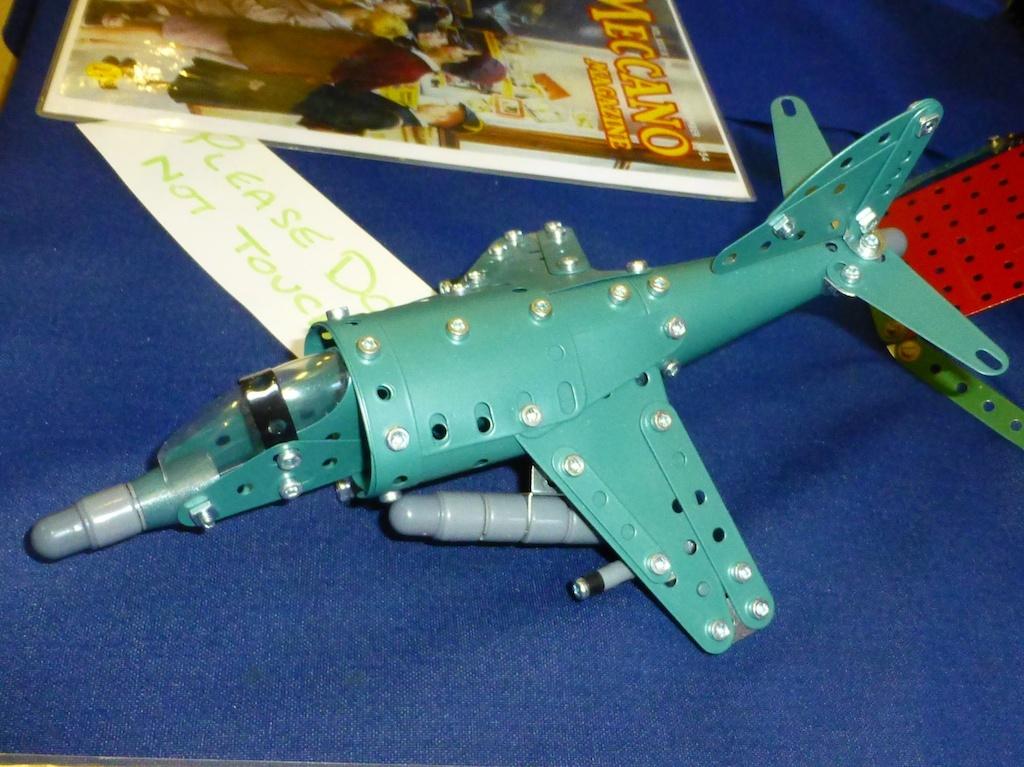What should you not do to this model?
Give a very brief answer. Touch. What is the word at the top of the poster in the back?
Make the answer very short. Meccano. 